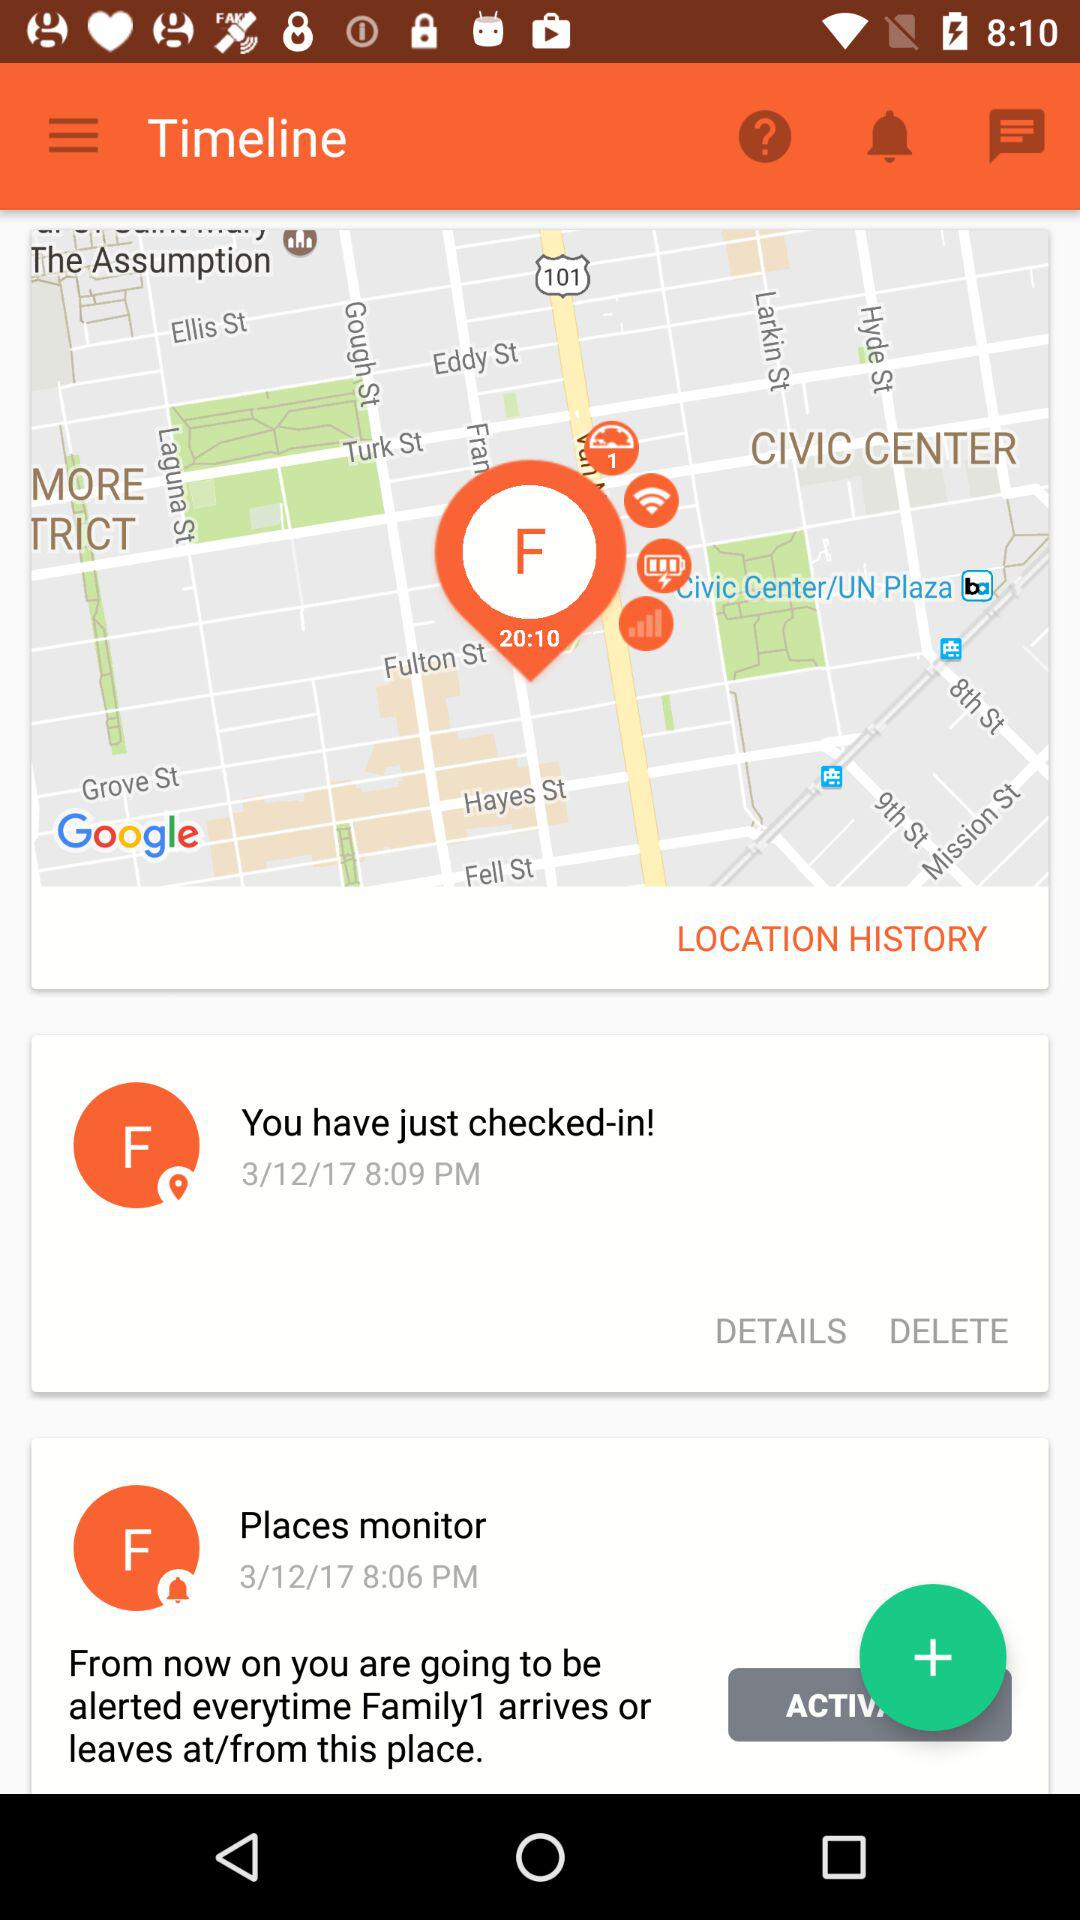How many active places monitors does the user have?
Answer the question using a single word or phrase. 1 